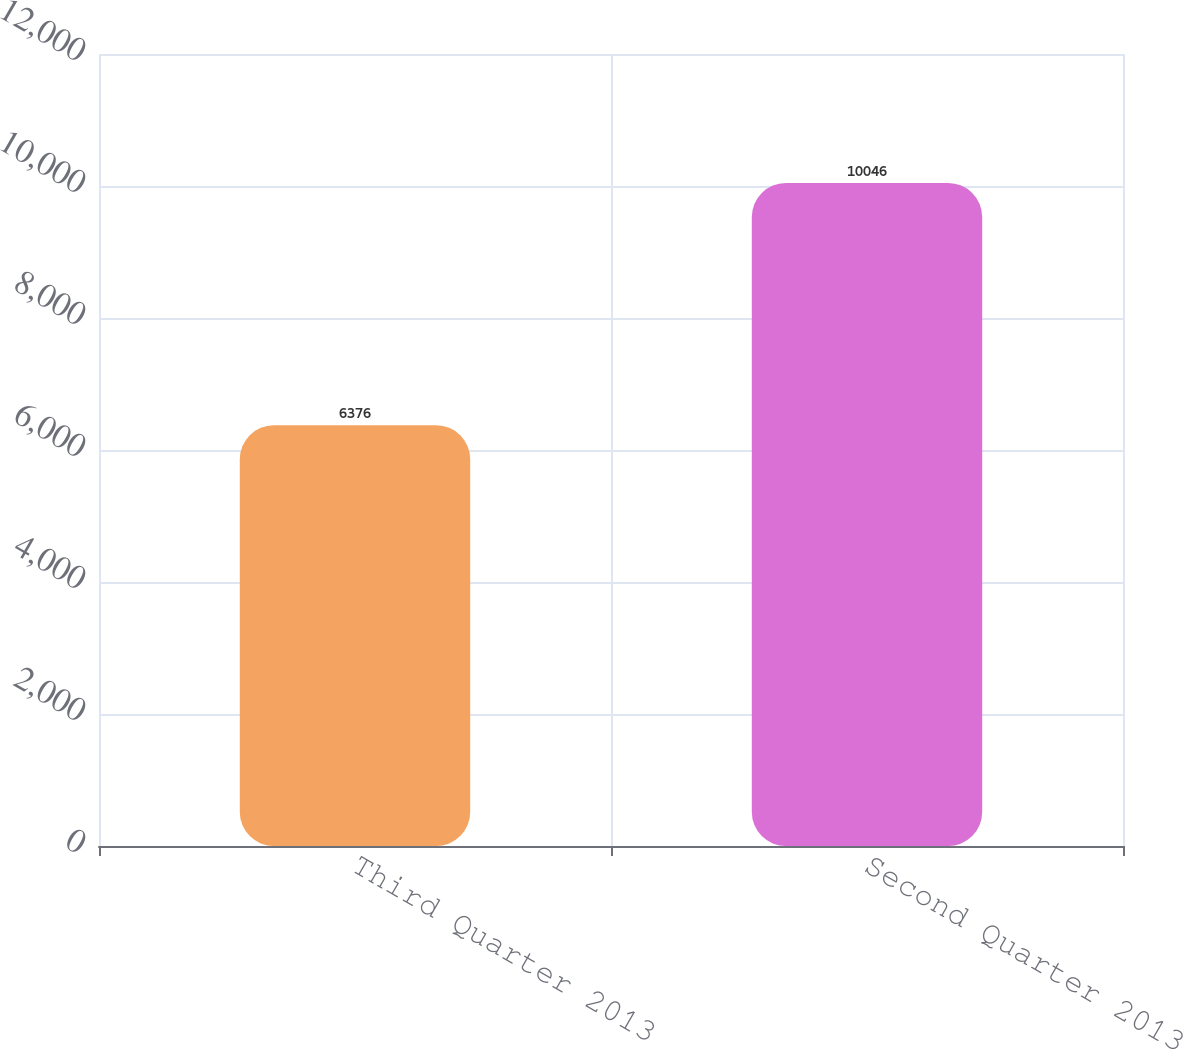Convert chart to OTSL. <chart><loc_0><loc_0><loc_500><loc_500><bar_chart><fcel>Third Quarter 2013<fcel>Second Quarter 2013<nl><fcel>6376<fcel>10046<nl></chart> 